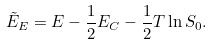Convert formula to latex. <formula><loc_0><loc_0><loc_500><loc_500>\tilde { E } _ { E } = E - \frac { 1 } { 2 } E _ { C } - \frac { 1 } { 2 } T \ln S _ { 0 } .</formula> 